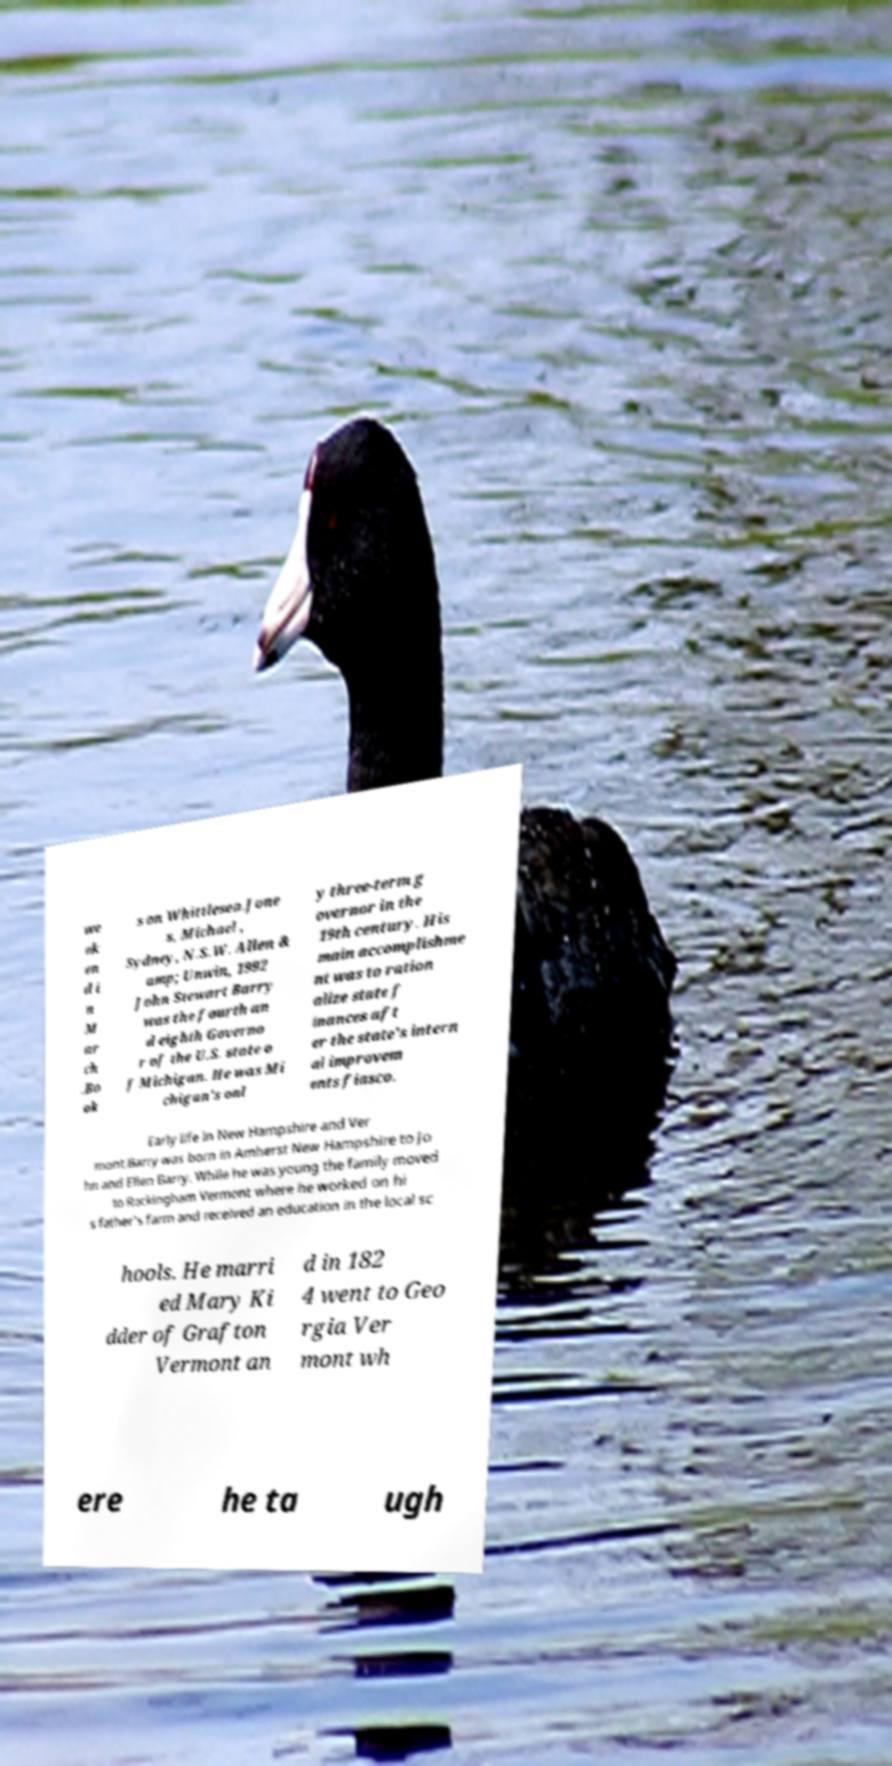Please read and relay the text visible in this image. What does it say? we ek en d i n M ar ch .Bo ok s on Whittlesea.Jone s, Michael , Sydney, N.S.W. Allen & amp; Unwin, 1992 John Stewart Barry was the fourth an d eighth Governo r of the U.S. state o f Michigan. He was Mi chigan's onl y three-term g overnor in the 19th century. His main accomplishme nt was to ration alize state f inances aft er the state's intern al improvem ents fiasco. Early life in New Hampshire and Ver mont.Barry was born in Amherst New Hampshire to Jo hn and Ellen Barry. While he was young the family moved to Rockingham Vermont where he worked on hi s father's farm and received an education in the local sc hools. He marri ed Mary Ki dder of Grafton Vermont an d in 182 4 went to Geo rgia Ver mont wh ere he ta ugh 